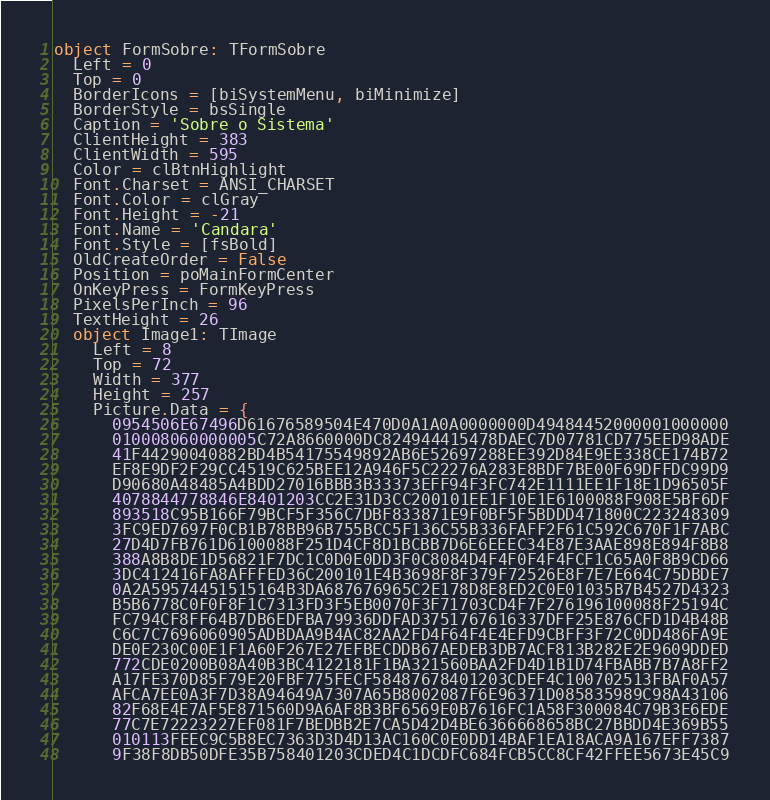Convert code to text. <code><loc_0><loc_0><loc_500><loc_500><_Pascal_>object FormSobre: TFormSobre
  Left = 0
  Top = 0
  BorderIcons = [biSystemMenu, biMinimize]
  BorderStyle = bsSingle
  Caption = 'Sobre o Sistema'
  ClientHeight = 383
  ClientWidth = 595
  Color = clBtnHighlight
  Font.Charset = ANSI_CHARSET
  Font.Color = clGray
  Font.Height = -21
  Font.Name = 'Candara'
  Font.Style = [fsBold]
  OldCreateOrder = False
  Position = poMainFormCenter
  OnKeyPress = FormKeyPress
  PixelsPerInch = 96
  TextHeight = 26
  object Image1: TImage
    Left = 8
    Top = 72
    Width = 377
    Height = 257
    Picture.Data = {
      0954506E67496D61676589504E470D0A1A0A0000000D49484452000001000000
      010008060000005C72A8660000DC824944415478DAEC7D07781CD775EED98ADE
      41F44290040882BD4B54175549892AB6E52697288EE392D84E9EE338CE174B72
      EF8E9DF2F29CC4519C625BEE12A946F5C22276A283E8BDF7BE00F69DFFDC99D9
      D90680A48485A4BDD27016BBB3B33373EFF94F3FC742E1111EE1F18E1D96505F
      4078844778846E8401203CC2E31D3CC200101EE1F10E1E6100088F908E5BF6DF
      893518C95B166F79BCF5F356C7DBF833871E9F0BF5F5BDDD471800C223248309
      3FC9ED7697F0CB1B78BB96B755BCC5F136C55B336FAFF2F61C592C670F1F7ABC
      27D4D7FB761D6100088F251D4CF8D1BCBB7D6E6EEEC34E87E3AAE898E894F8B8
      388A8B8DE1D56821F7DC1C0D0E0DD3F0C8084D4F4F0F4F4FCF1C65A0F8B9CD66
      3DC412416FA8AFFFED36C200101E4B3698F8F379F72526E8F7E7E664C75DBDE7
      0A2A59574451515164B3DA687676965C2E178D8E8ED2C0E01035B7B4527D4323
      B5B6778C0F0F8F1C7313FD3F5EB0070F3F71703CD4F7F276196100088F25194C
      FC794CF8FF64B7DB6EDFBA79936DDFAD3751767616337DFF25E876CFD1D4B48B
      C6C7C7696060905ADBDAA9B4AC82AA2FD4F64F4E4EFD9CBFF3F72C0DD486FA9E
      DE0E230C00E1F1A60F267E27EFBECDDB67AEDEB3DB7ACF813B282E2E9609DDED
      772CDE0200B08A40B3BC4122181F1BA321560BAA2FD4D1B1D74FBABB7B7A8FF2
      A17FE370D85F79E20FBF775FECF58487678401203CDEF4C100702513FBAF0A57
      AFCA7EE0A3F7D38A94649A7307A65B8002087F6E96371D085835989C98A43106
      82F68E4E7AF5E871560D9A6AF8B3BF6569E0B7616FC1A58F300084C79B3E6EDE
      77C7E72223227EF081F7BEDBB2E7CA5D42D4BE6366668658BC27BBDD4E369B55
      010113FEEC9C5B8EC7363D3D4D13AC160C0E0DD14BAF1EA18ACA9A167EFF7387
      9F38F8DB50DFE35B758401203CDED4C1DCDFC684FCB5CC8CF42FFEE5673E45C9</code> 